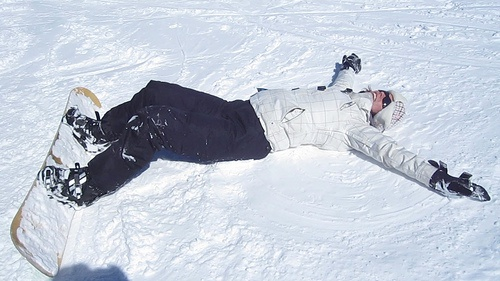Describe the objects in this image and their specific colors. I can see people in lavender, lightgray, black, and darkgray tones and snowboard in lavender, lightgray, darkgray, and gray tones in this image. 